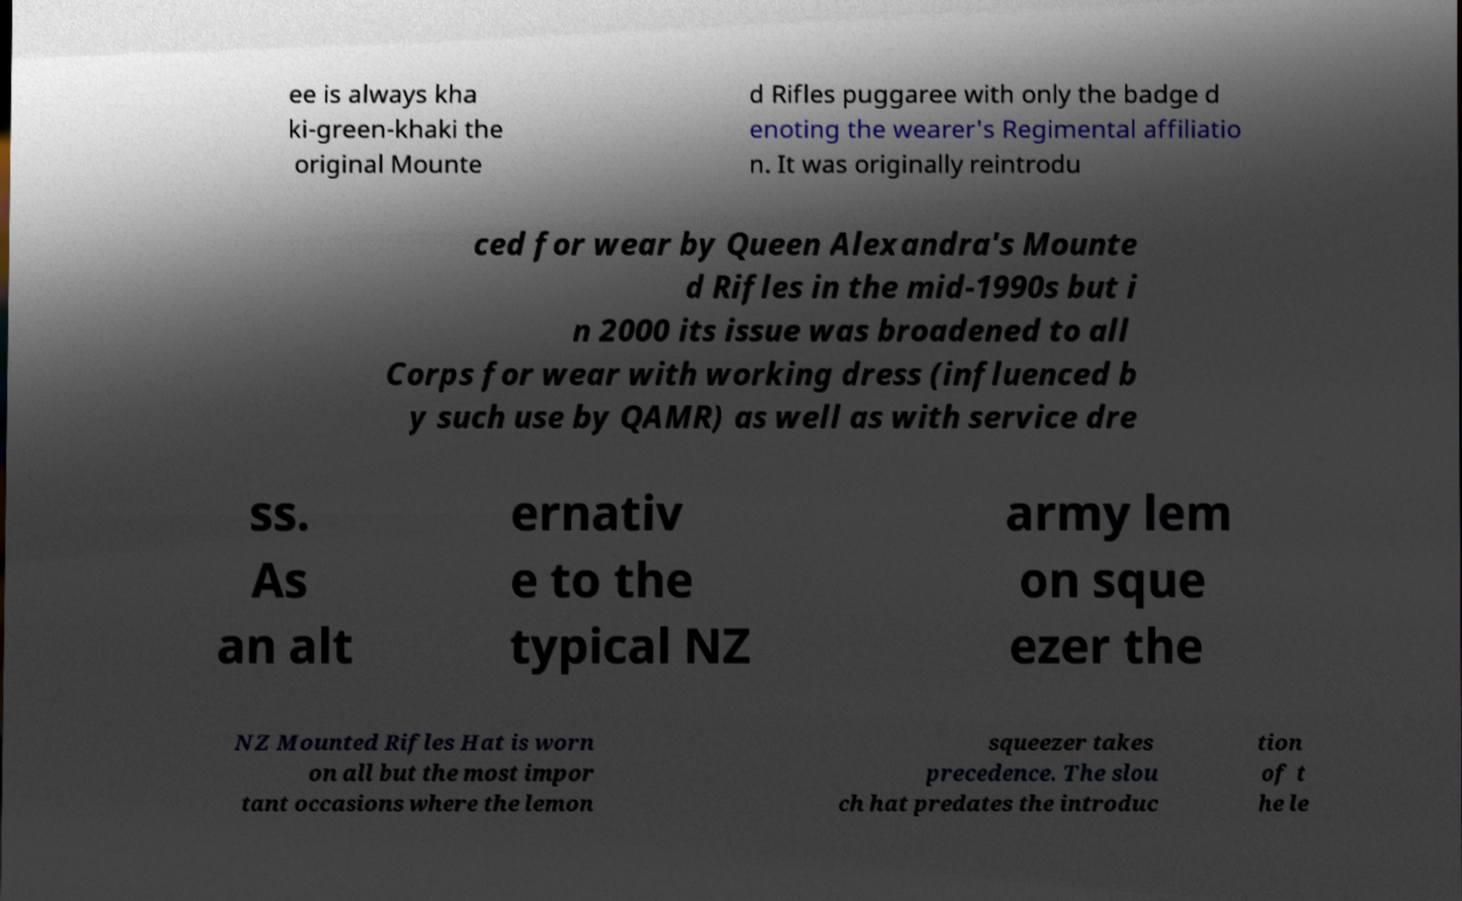Could you assist in decoding the text presented in this image and type it out clearly? ee is always kha ki-green-khaki the original Mounte d Rifles puggaree with only the badge d enoting the wearer's Regimental affiliatio n. It was originally reintrodu ced for wear by Queen Alexandra's Mounte d Rifles in the mid-1990s but i n 2000 its issue was broadened to all Corps for wear with working dress (influenced b y such use by QAMR) as well as with service dre ss. As an alt ernativ e to the typical NZ army lem on sque ezer the NZ Mounted Rifles Hat is worn on all but the most impor tant occasions where the lemon squeezer takes precedence. The slou ch hat predates the introduc tion of t he le 